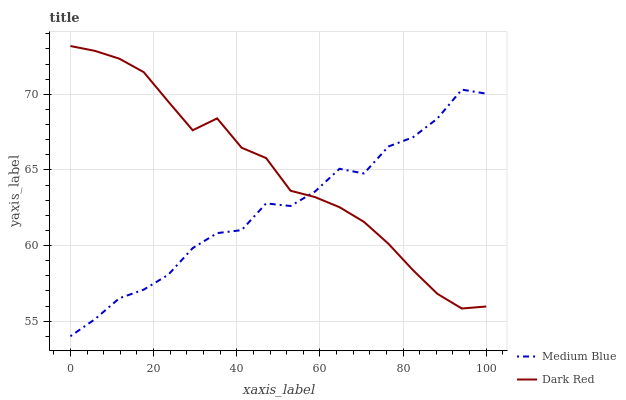Does Medium Blue have the minimum area under the curve?
Answer yes or no. Yes. Does Dark Red have the maximum area under the curve?
Answer yes or no. Yes. Does Medium Blue have the maximum area under the curve?
Answer yes or no. No. Is Dark Red the smoothest?
Answer yes or no. Yes. Is Medium Blue the roughest?
Answer yes or no. Yes. Is Medium Blue the smoothest?
Answer yes or no. No. Does Medium Blue have the lowest value?
Answer yes or no. Yes. Does Dark Red have the highest value?
Answer yes or no. Yes. Does Medium Blue have the highest value?
Answer yes or no. No. Does Dark Red intersect Medium Blue?
Answer yes or no. Yes. Is Dark Red less than Medium Blue?
Answer yes or no. No. Is Dark Red greater than Medium Blue?
Answer yes or no. No. 